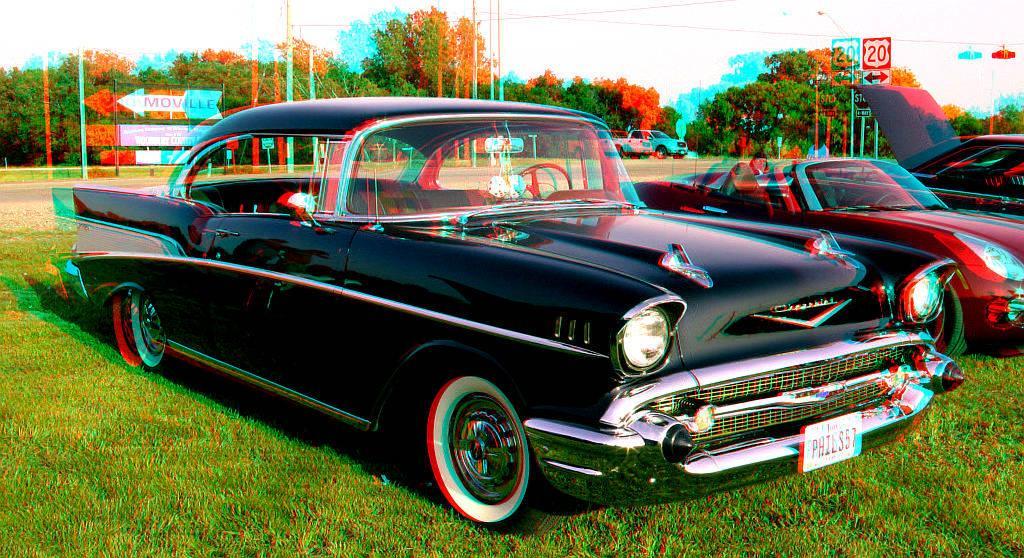In one or two sentences, can you explain what this image depicts? This is an edited picture. In the foreground of the picture there are cars and grass. In the background there are trees, car, current poles, cables, sign boards and grass. 